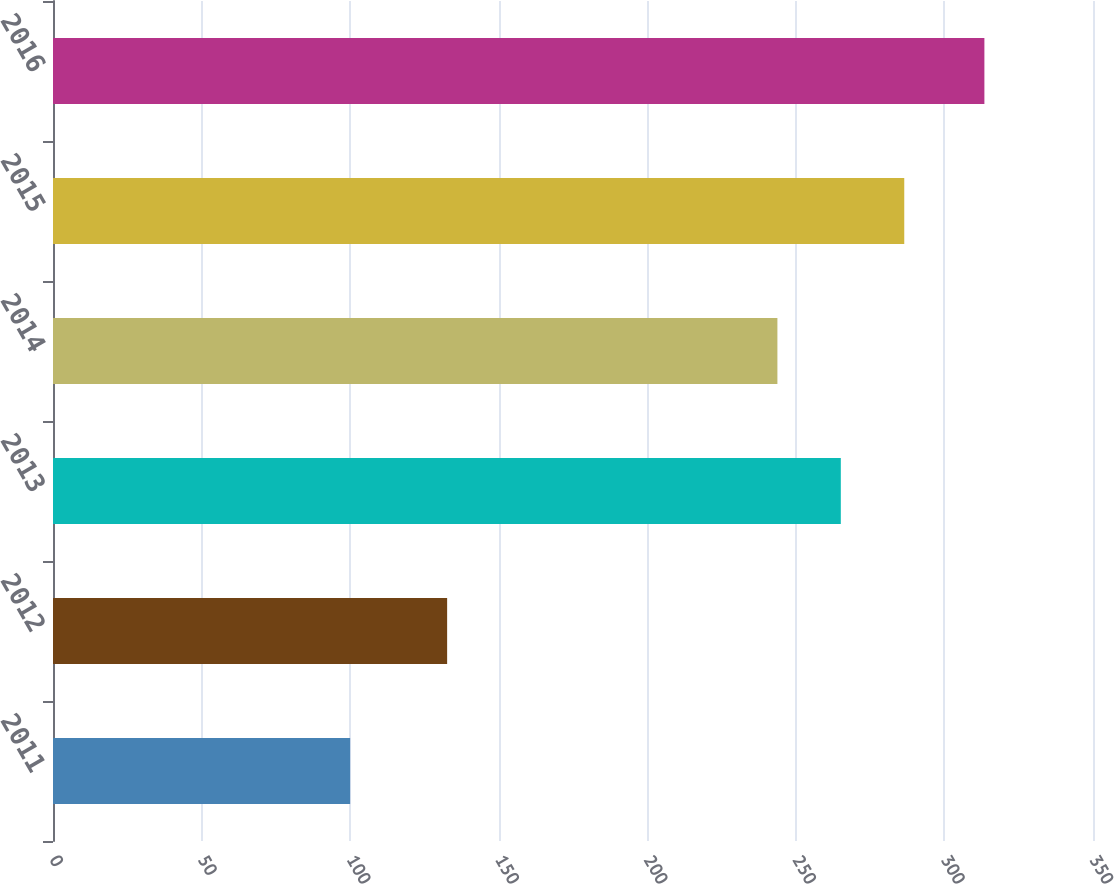<chart> <loc_0><loc_0><loc_500><loc_500><bar_chart><fcel>2011<fcel>2012<fcel>2013<fcel>2014<fcel>2015<fcel>2016<nl><fcel>100<fcel>132.64<fcel>265.13<fcel>243.79<fcel>286.48<fcel>313.45<nl></chart> 